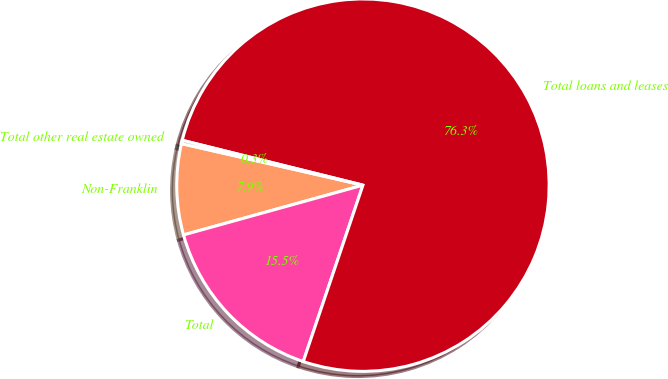Convert chart to OTSL. <chart><loc_0><loc_0><loc_500><loc_500><pie_chart><fcel>Non-Franklin<fcel>Total<fcel>Total loans and leases<fcel>Total other real estate owned<nl><fcel>7.89%<fcel>15.5%<fcel>76.32%<fcel>0.29%<nl></chart> 